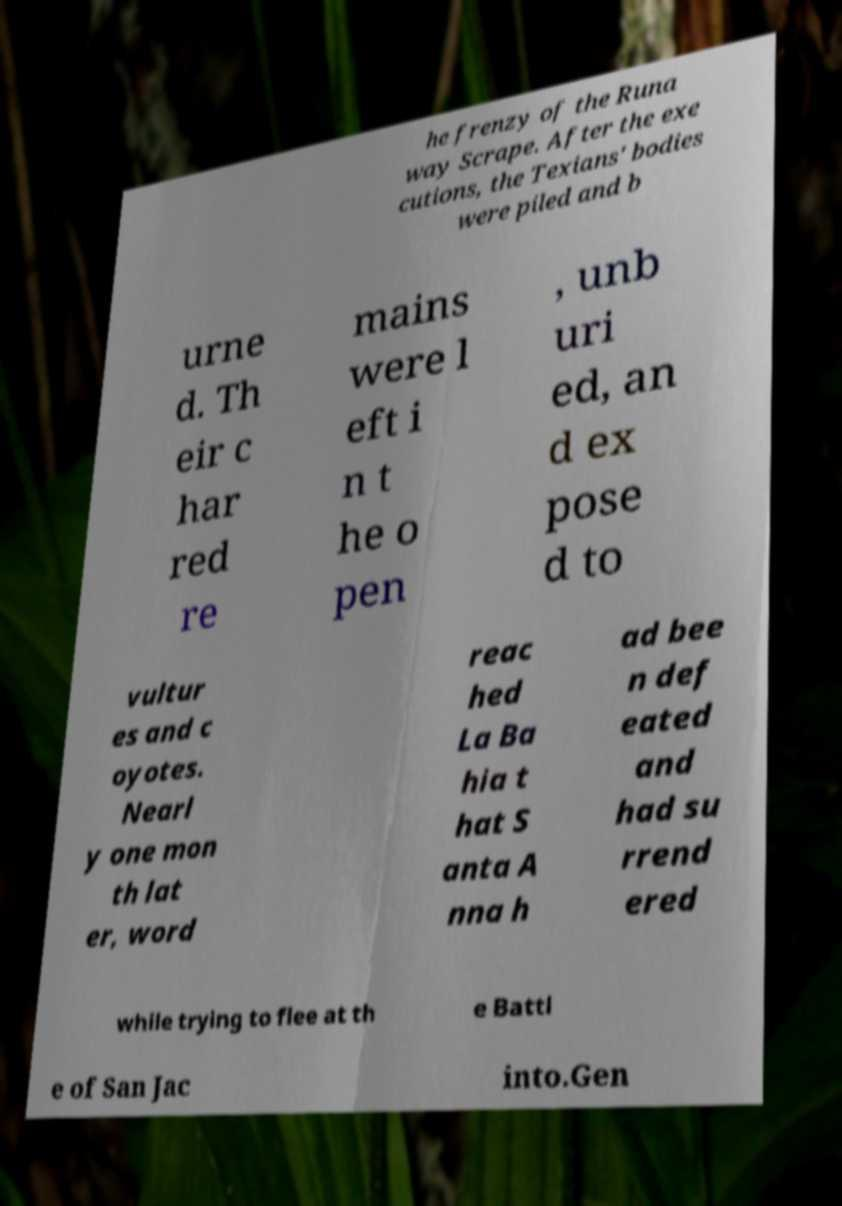Could you extract and type out the text from this image? he frenzy of the Runa way Scrape. After the exe cutions, the Texians' bodies were piled and b urne d. Th eir c har red re mains were l eft i n t he o pen , unb uri ed, an d ex pose d to vultur es and c oyotes. Nearl y one mon th lat er, word reac hed La Ba hia t hat S anta A nna h ad bee n def eated and had su rrend ered while trying to flee at th e Battl e of San Jac into.Gen 